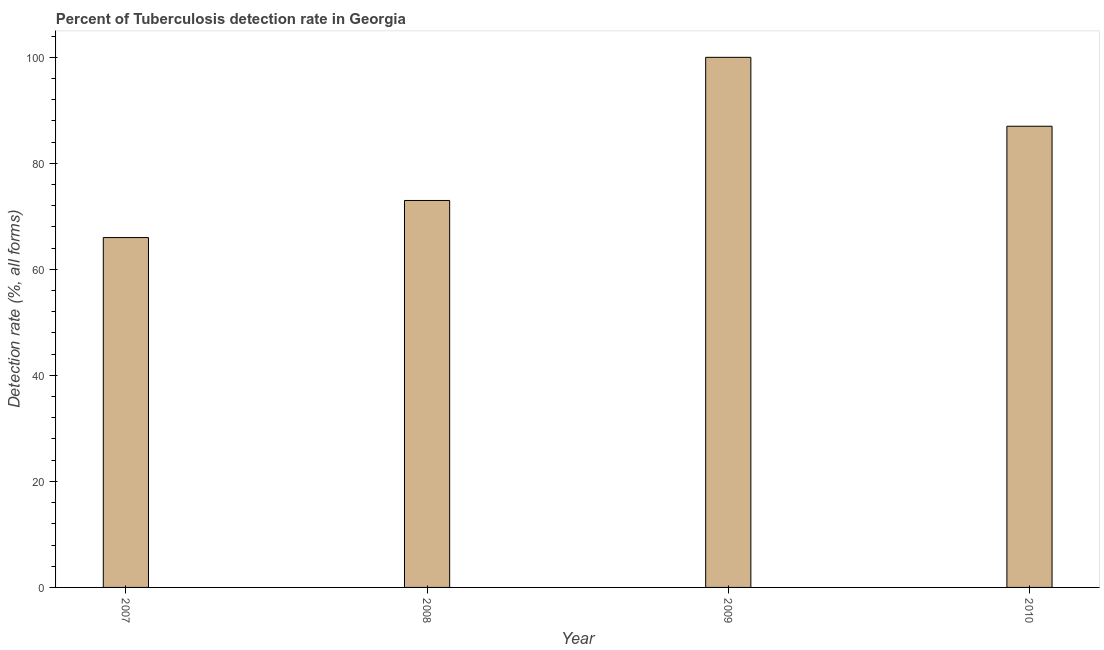Does the graph contain any zero values?
Give a very brief answer. No. What is the title of the graph?
Give a very brief answer. Percent of Tuberculosis detection rate in Georgia. What is the label or title of the Y-axis?
Provide a succinct answer. Detection rate (%, all forms). Across all years, what is the minimum detection rate of tuberculosis?
Offer a very short reply. 66. In which year was the detection rate of tuberculosis maximum?
Ensure brevity in your answer.  2009. In which year was the detection rate of tuberculosis minimum?
Your response must be concise. 2007. What is the sum of the detection rate of tuberculosis?
Offer a very short reply. 326. What is the difference between the detection rate of tuberculosis in 2007 and 2010?
Your response must be concise. -21. What is the median detection rate of tuberculosis?
Ensure brevity in your answer.  80. In how many years, is the detection rate of tuberculosis greater than 36 %?
Give a very brief answer. 4. What is the ratio of the detection rate of tuberculosis in 2008 to that in 2010?
Give a very brief answer. 0.84. What is the difference between the highest and the second highest detection rate of tuberculosis?
Your answer should be very brief. 13. Is the sum of the detection rate of tuberculosis in 2007 and 2010 greater than the maximum detection rate of tuberculosis across all years?
Your answer should be very brief. Yes. How many years are there in the graph?
Keep it short and to the point. 4. What is the difference between two consecutive major ticks on the Y-axis?
Offer a very short reply. 20. Are the values on the major ticks of Y-axis written in scientific E-notation?
Keep it short and to the point. No. What is the Detection rate (%, all forms) in 2007?
Provide a short and direct response. 66. What is the Detection rate (%, all forms) of 2008?
Provide a short and direct response. 73. What is the difference between the Detection rate (%, all forms) in 2007 and 2009?
Offer a terse response. -34. What is the difference between the Detection rate (%, all forms) in 2007 and 2010?
Ensure brevity in your answer.  -21. What is the difference between the Detection rate (%, all forms) in 2008 and 2010?
Give a very brief answer. -14. What is the difference between the Detection rate (%, all forms) in 2009 and 2010?
Ensure brevity in your answer.  13. What is the ratio of the Detection rate (%, all forms) in 2007 to that in 2008?
Your answer should be very brief. 0.9. What is the ratio of the Detection rate (%, all forms) in 2007 to that in 2009?
Offer a terse response. 0.66. What is the ratio of the Detection rate (%, all forms) in 2007 to that in 2010?
Your answer should be compact. 0.76. What is the ratio of the Detection rate (%, all forms) in 2008 to that in 2009?
Ensure brevity in your answer.  0.73. What is the ratio of the Detection rate (%, all forms) in 2008 to that in 2010?
Provide a short and direct response. 0.84. What is the ratio of the Detection rate (%, all forms) in 2009 to that in 2010?
Your answer should be very brief. 1.15. 